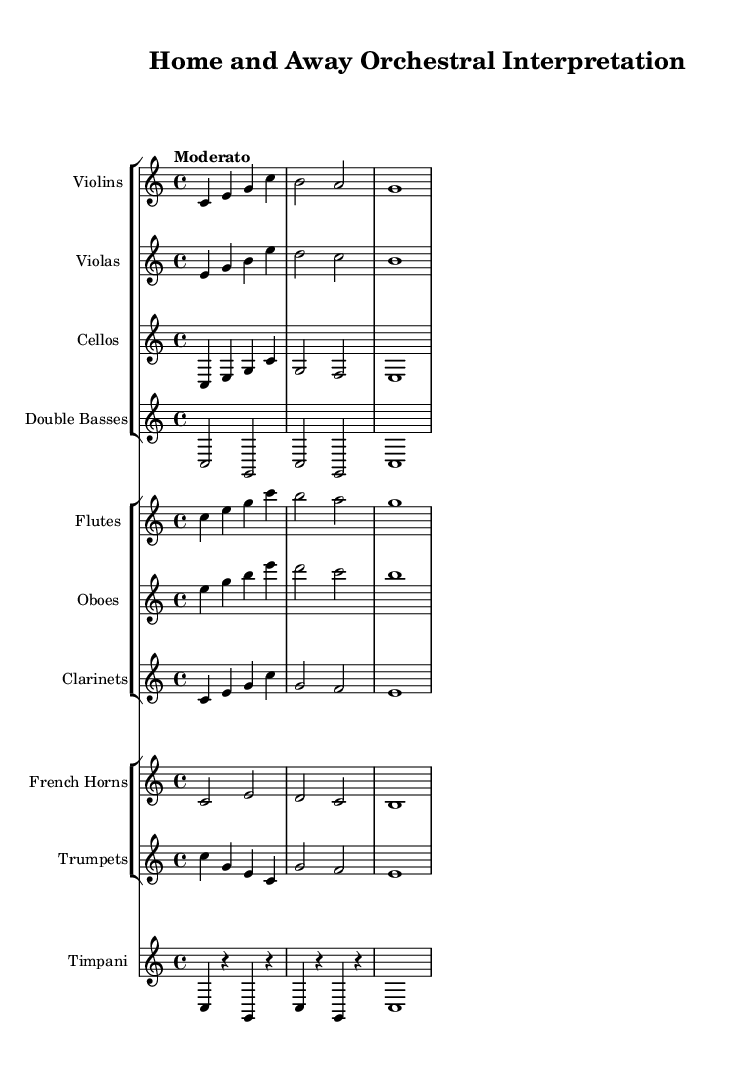What is the key signature of this music? The key signature is found at the beginning of the sheet music, and it indicates C major, which has no sharps or flats.
Answer: C major What is the time signature of this music? The time signature is indicated at the beginning of the score, showing that it is in 4/4, meaning there are four beats per measure.
Answer: 4/4 What is the tempo marking in this music? The tempo marking is specified at the top of the score, which indicates "Moderato," suggesting a moderately paced tempo.
Answer: Moderato How many instruments are in the string section? By looking at the groups, there are four types of instruments listed in the string section: violins, violas, cellos, and double basses. Adding those together results in four instruments.
Answer: 4 Which instrument plays the highest pitch in this score? The flutes are the highest-pitched instruments in this orchestral score, usually playing an octave or more higher than the other woodwinds and strings.
Answer: Flutes What is the notation for the timpani part? The timpani part consists of quarter notes and rests in C, followed by repeated notes on G and C, indicating rhythmic and melodic contrasts.
Answer: C4, R, G, R Which section contains brass instruments in this orchestra? Brass instruments are located in the group labeled "French Horns" and "Trumpets," as they are specifically included in the brass section of the score.
Answer: French Horns, Trumpets 